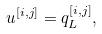<formula> <loc_0><loc_0><loc_500><loc_500>u ^ { [ i , j ] } = q ^ { [ i , j ] } _ { L } ,</formula> 